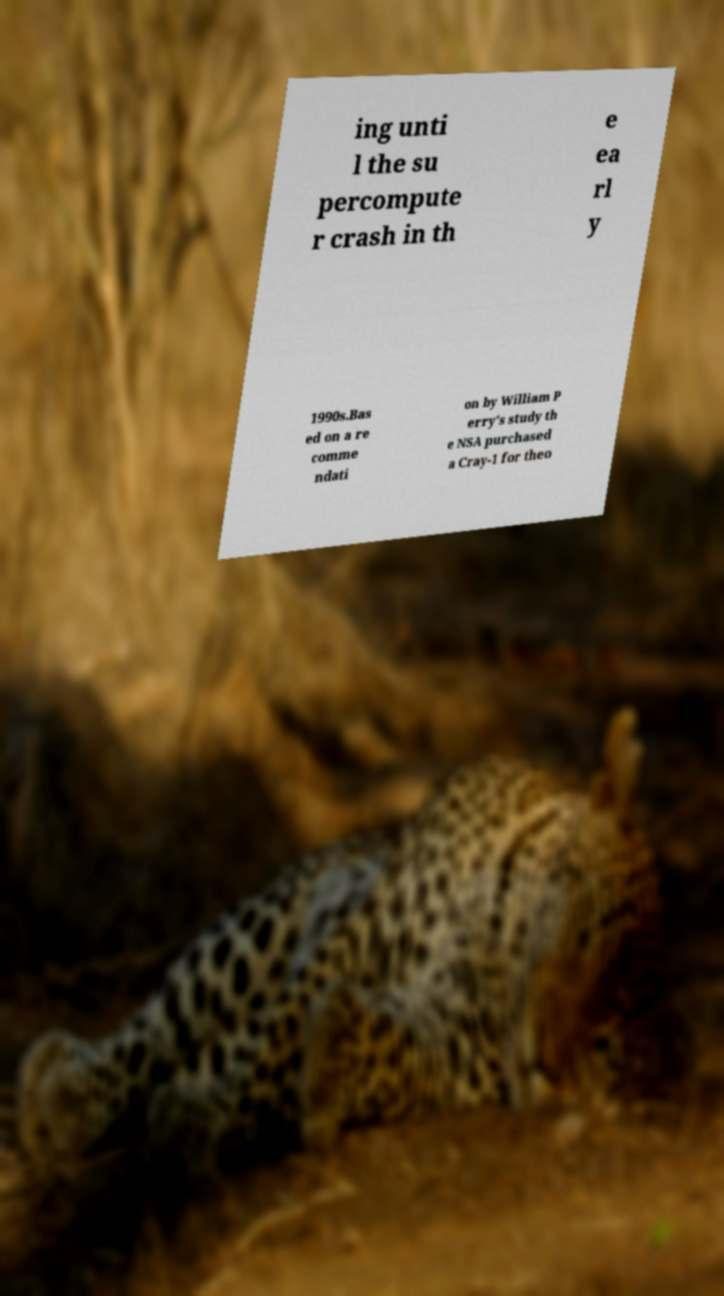Could you extract and type out the text from this image? ing unti l the su percompute r crash in th e ea rl y 1990s.Bas ed on a re comme ndati on by William P erry's study th e NSA purchased a Cray-1 for theo 